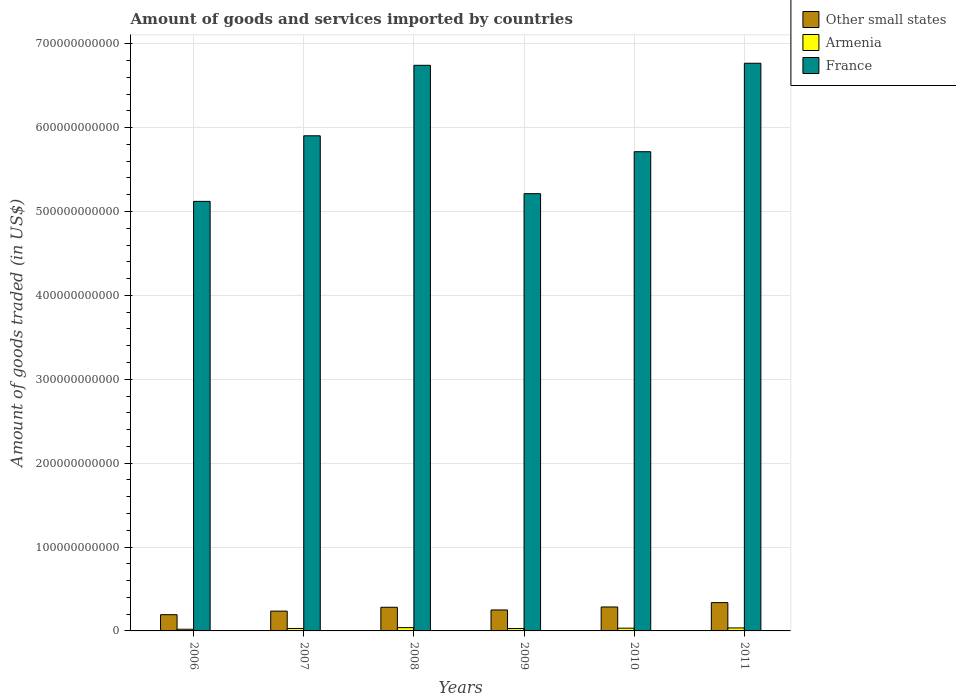How many groups of bars are there?
Your answer should be compact. 6. Are the number of bars on each tick of the X-axis equal?
Provide a succinct answer. Yes. How many bars are there on the 2nd tick from the left?
Provide a short and direct response. 3. What is the label of the 3rd group of bars from the left?
Your answer should be compact. 2008. What is the total amount of goods and services imported in France in 2011?
Keep it short and to the point. 6.77e+11. Across all years, what is the maximum total amount of goods and services imported in France?
Your answer should be very brief. 6.77e+11. Across all years, what is the minimum total amount of goods and services imported in Other small states?
Your response must be concise. 1.93e+1. In which year was the total amount of goods and services imported in Other small states minimum?
Keep it short and to the point. 2006. What is the total total amount of goods and services imported in Armenia in the graph?
Provide a succinct answer. 1.85e+1. What is the difference between the total amount of goods and services imported in Armenia in 2007 and that in 2008?
Offer a very short reply. -1.00e+09. What is the difference between the total amount of goods and services imported in Armenia in 2008 and the total amount of goods and services imported in France in 2006?
Ensure brevity in your answer.  -5.08e+11. What is the average total amount of goods and services imported in Armenia per year?
Your response must be concise. 3.09e+09. In the year 2007, what is the difference between the total amount of goods and services imported in Other small states and total amount of goods and services imported in France?
Give a very brief answer. -5.67e+11. What is the ratio of the total amount of goods and services imported in Armenia in 2006 to that in 2010?
Give a very brief answer. 0.61. Is the difference between the total amount of goods and services imported in Other small states in 2007 and 2011 greater than the difference between the total amount of goods and services imported in France in 2007 and 2011?
Provide a succinct answer. Yes. What is the difference between the highest and the second highest total amount of goods and services imported in Armenia?
Ensure brevity in your answer.  3.81e+08. What is the difference between the highest and the lowest total amount of goods and services imported in France?
Your answer should be very brief. 1.65e+11. In how many years, is the total amount of goods and services imported in Armenia greater than the average total amount of goods and services imported in Armenia taken over all years?
Make the answer very short. 3. Is the sum of the total amount of goods and services imported in France in 2009 and 2011 greater than the maximum total amount of goods and services imported in Armenia across all years?
Make the answer very short. Yes. What does the 2nd bar from the left in 2006 represents?
Your response must be concise. Armenia. What does the 2nd bar from the right in 2009 represents?
Your answer should be very brief. Armenia. Is it the case that in every year, the sum of the total amount of goods and services imported in France and total amount of goods and services imported in Armenia is greater than the total amount of goods and services imported in Other small states?
Provide a succinct answer. Yes. How many bars are there?
Offer a very short reply. 18. How many years are there in the graph?
Your answer should be very brief. 6. What is the difference between two consecutive major ticks on the Y-axis?
Your answer should be very brief. 1.00e+11. Does the graph contain grids?
Provide a short and direct response. Yes. Where does the legend appear in the graph?
Ensure brevity in your answer.  Top right. How many legend labels are there?
Provide a succinct answer. 3. How are the legend labels stacked?
Offer a terse response. Vertical. What is the title of the graph?
Keep it short and to the point. Amount of goods and services imported by countries. Does "East Asia (all income levels)" appear as one of the legend labels in the graph?
Provide a short and direct response. No. What is the label or title of the Y-axis?
Provide a short and direct response. Amount of goods traded (in US$). What is the Amount of goods traded (in US$) in Other small states in 2006?
Provide a short and direct response. 1.93e+1. What is the Amount of goods traded (in US$) of Armenia in 2006?
Offer a very short reply. 2.00e+09. What is the Amount of goods traded (in US$) of France in 2006?
Offer a very short reply. 5.12e+11. What is the Amount of goods traded (in US$) in Other small states in 2007?
Give a very brief answer. 2.36e+1. What is the Amount of goods traded (in US$) of Armenia in 2007?
Provide a short and direct response. 2.92e+09. What is the Amount of goods traded (in US$) of France in 2007?
Offer a very short reply. 5.90e+11. What is the Amount of goods traded (in US$) of Other small states in 2008?
Ensure brevity in your answer.  2.82e+1. What is the Amount of goods traded (in US$) of Armenia in 2008?
Offer a very short reply. 3.92e+09. What is the Amount of goods traded (in US$) of France in 2008?
Ensure brevity in your answer.  6.74e+11. What is the Amount of goods traded (in US$) in Other small states in 2009?
Your answer should be very brief. 2.50e+1. What is the Amount of goods traded (in US$) of Armenia in 2009?
Provide a succinct answer. 2.86e+09. What is the Amount of goods traded (in US$) in France in 2009?
Ensure brevity in your answer.  5.21e+11. What is the Amount of goods traded (in US$) in Other small states in 2010?
Make the answer very short. 2.86e+1. What is the Amount of goods traded (in US$) of Armenia in 2010?
Your answer should be very brief. 3.26e+09. What is the Amount of goods traded (in US$) of France in 2010?
Give a very brief answer. 5.71e+11. What is the Amount of goods traded (in US$) in Other small states in 2011?
Offer a very short reply. 3.37e+1. What is the Amount of goods traded (in US$) of Armenia in 2011?
Your response must be concise. 3.54e+09. What is the Amount of goods traded (in US$) in France in 2011?
Provide a short and direct response. 6.77e+11. Across all years, what is the maximum Amount of goods traded (in US$) of Other small states?
Ensure brevity in your answer.  3.37e+1. Across all years, what is the maximum Amount of goods traded (in US$) in Armenia?
Ensure brevity in your answer.  3.92e+09. Across all years, what is the maximum Amount of goods traded (in US$) of France?
Make the answer very short. 6.77e+11. Across all years, what is the minimum Amount of goods traded (in US$) of Other small states?
Provide a succinct answer. 1.93e+1. Across all years, what is the minimum Amount of goods traded (in US$) in Armenia?
Offer a very short reply. 2.00e+09. Across all years, what is the minimum Amount of goods traded (in US$) of France?
Your answer should be very brief. 5.12e+11. What is the total Amount of goods traded (in US$) of Other small states in the graph?
Give a very brief answer. 1.58e+11. What is the total Amount of goods traded (in US$) of Armenia in the graph?
Your answer should be compact. 1.85e+1. What is the total Amount of goods traded (in US$) of France in the graph?
Your answer should be very brief. 3.55e+12. What is the difference between the Amount of goods traded (in US$) of Other small states in 2006 and that in 2007?
Give a very brief answer. -4.27e+09. What is the difference between the Amount of goods traded (in US$) in Armenia in 2006 and that in 2007?
Offer a terse response. -9.21e+08. What is the difference between the Amount of goods traded (in US$) in France in 2006 and that in 2007?
Offer a terse response. -7.82e+1. What is the difference between the Amount of goods traded (in US$) of Other small states in 2006 and that in 2008?
Your answer should be compact. -8.85e+09. What is the difference between the Amount of goods traded (in US$) of Armenia in 2006 and that in 2008?
Offer a terse response. -1.92e+09. What is the difference between the Amount of goods traded (in US$) in France in 2006 and that in 2008?
Ensure brevity in your answer.  -1.62e+11. What is the difference between the Amount of goods traded (in US$) of Other small states in 2006 and that in 2009?
Provide a succinct answer. -5.65e+09. What is the difference between the Amount of goods traded (in US$) in Armenia in 2006 and that in 2009?
Offer a terse response. -8.64e+08. What is the difference between the Amount of goods traded (in US$) in France in 2006 and that in 2009?
Your answer should be compact. -9.15e+09. What is the difference between the Amount of goods traded (in US$) in Other small states in 2006 and that in 2010?
Give a very brief answer. -9.21e+09. What is the difference between the Amount of goods traded (in US$) of Armenia in 2006 and that in 2010?
Ensure brevity in your answer.  -1.26e+09. What is the difference between the Amount of goods traded (in US$) in France in 2006 and that in 2010?
Offer a terse response. -5.92e+1. What is the difference between the Amount of goods traded (in US$) in Other small states in 2006 and that in 2011?
Offer a very short reply. -1.44e+1. What is the difference between the Amount of goods traded (in US$) in Armenia in 2006 and that in 2011?
Give a very brief answer. -1.54e+09. What is the difference between the Amount of goods traded (in US$) in France in 2006 and that in 2011?
Ensure brevity in your answer.  -1.65e+11. What is the difference between the Amount of goods traded (in US$) in Other small states in 2007 and that in 2008?
Your answer should be very brief. -4.57e+09. What is the difference between the Amount of goods traded (in US$) in Armenia in 2007 and that in 2008?
Keep it short and to the point. -1.00e+09. What is the difference between the Amount of goods traded (in US$) in France in 2007 and that in 2008?
Offer a terse response. -8.40e+1. What is the difference between the Amount of goods traded (in US$) in Other small states in 2007 and that in 2009?
Make the answer very short. -1.38e+09. What is the difference between the Amount of goods traded (in US$) of Armenia in 2007 and that in 2009?
Offer a terse response. 5.75e+07. What is the difference between the Amount of goods traded (in US$) in France in 2007 and that in 2009?
Make the answer very short. 6.90e+1. What is the difference between the Amount of goods traded (in US$) of Other small states in 2007 and that in 2010?
Make the answer very short. -4.94e+09. What is the difference between the Amount of goods traded (in US$) of Armenia in 2007 and that in 2010?
Your answer should be compact. -3.42e+08. What is the difference between the Amount of goods traded (in US$) in France in 2007 and that in 2010?
Your answer should be compact. 1.90e+1. What is the difference between the Amount of goods traded (in US$) of Other small states in 2007 and that in 2011?
Provide a short and direct response. -1.01e+1. What is the difference between the Amount of goods traded (in US$) in Armenia in 2007 and that in 2011?
Offer a very short reply. -6.20e+08. What is the difference between the Amount of goods traded (in US$) of France in 2007 and that in 2011?
Give a very brief answer. -8.65e+1. What is the difference between the Amount of goods traded (in US$) of Other small states in 2008 and that in 2009?
Give a very brief answer. 3.19e+09. What is the difference between the Amount of goods traded (in US$) of Armenia in 2008 and that in 2009?
Offer a terse response. 1.06e+09. What is the difference between the Amount of goods traded (in US$) in France in 2008 and that in 2009?
Offer a very short reply. 1.53e+11. What is the difference between the Amount of goods traded (in US$) of Other small states in 2008 and that in 2010?
Your response must be concise. -3.67e+08. What is the difference between the Amount of goods traded (in US$) of Armenia in 2008 and that in 2010?
Give a very brief answer. 6.59e+08. What is the difference between the Amount of goods traded (in US$) in France in 2008 and that in 2010?
Offer a terse response. 1.03e+11. What is the difference between the Amount of goods traded (in US$) of Other small states in 2008 and that in 2011?
Make the answer very short. -5.55e+09. What is the difference between the Amount of goods traded (in US$) in Armenia in 2008 and that in 2011?
Make the answer very short. 3.81e+08. What is the difference between the Amount of goods traded (in US$) in France in 2008 and that in 2011?
Your answer should be compact. -2.45e+09. What is the difference between the Amount of goods traded (in US$) of Other small states in 2009 and that in 2010?
Keep it short and to the point. -3.56e+09. What is the difference between the Amount of goods traded (in US$) in Armenia in 2009 and that in 2010?
Provide a succinct answer. -4.00e+08. What is the difference between the Amount of goods traded (in US$) in France in 2009 and that in 2010?
Your response must be concise. -5.01e+1. What is the difference between the Amount of goods traded (in US$) of Other small states in 2009 and that in 2011?
Your answer should be compact. -8.75e+09. What is the difference between the Amount of goods traded (in US$) in Armenia in 2009 and that in 2011?
Keep it short and to the point. -6.78e+08. What is the difference between the Amount of goods traded (in US$) in France in 2009 and that in 2011?
Provide a short and direct response. -1.56e+11. What is the difference between the Amount of goods traded (in US$) of Other small states in 2010 and that in 2011?
Offer a very short reply. -5.18e+09. What is the difference between the Amount of goods traded (in US$) in Armenia in 2010 and that in 2011?
Make the answer very short. -2.78e+08. What is the difference between the Amount of goods traded (in US$) in France in 2010 and that in 2011?
Provide a short and direct response. -1.05e+11. What is the difference between the Amount of goods traded (in US$) of Other small states in 2006 and the Amount of goods traded (in US$) of Armenia in 2007?
Make the answer very short. 1.64e+1. What is the difference between the Amount of goods traded (in US$) in Other small states in 2006 and the Amount of goods traded (in US$) in France in 2007?
Provide a succinct answer. -5.71e+11. What is the difference between the Amount of goods traded (in US$) in Armenia in 2006 and the Amount of goods traded (in US$) in France in 2007?
Your answer should be very brief. -5.88e+11. What is the difference between the Amount of goods traded (in US$) of Other small states in 2006 and the Amount of goods traded (in US$) of Armenia in 2008?
Keep it short and to the point. 1.54e+1. What is the difference between the Amount of goods traded (in US$) in Other small states in 2006 and the Amount of goods traded (in US$) in France in 2008?
Keep it short and to the point. -6.55e+11. What is the difference between the Amount of goods traded (in US$) in Armenia in 2006 and the Amount of goods traded (in US$) in France in 2008?
Your response must be concise. -6.72e+11. What is the difference between the Amount of goods traded (in US$) in Other small states in 2006 and the Amount of goods traded (in US$) in Armenia in 2009?
Provide a short and direct response. 1.65e+1. What is the difference between the Amount of goods traded (in US$) of Other small states in 2006 and the Amount of goods traded (in US$) of France in 2009?
Your response must be concise. -5.02e+11. What is the difference between the Amount of goods traded (in US$) in Armenia in 2006 and the Amount of goods traded (in US$) in France in 2009?
Your answer should be very brief. -5.19e+11. What is the difference between the Amount of goods traded (in US$) in Other small states in 2006 and the Amount of goods traded (in US$) in Armenia in 2010?
Ensure brevity in your answer.  1.61e+1. What is the difference between the Amount of goods traded (in US$) of Other small states in 2006 and the Amount of goods traded (in US$) of France in 2010?
Make the answer very short. -5.52e+11. What is the difference between the Amount of goods traded (in US$) in Armenia in 2006 and the Amount of goods traded (in US$) in France in 2010?
Ensure brevity in your answer.  -5.69e+11. What is the difference between the Amount of goods traded (in US$) of Other small states in 2006 and the Amount of goods traded (in US$) of Armenia in 2011?
Ensure brevity in your answer.  1.58e+1. What is the difference between the Amount of goods traded (in US$) of Other small states in 2006 and the Amount of goods traded (in US$) of France in 2011?
Your answer should be very brief. -6.57e+11. What is the difference between the Amount of goods traded (in US$) of Armenia in 2006 and the Amount of goods traded (in US$) of France in 2011?
Keep it short and to the point. -6.75e+11. What is the difference between the Amount of goods traded (in US$) in Other small states in 2007 and the Amount of goods traded (in US$) in Armenia in 2008?
Offer a very short reply. 1.97e+1. What is the difference between the Amount of goods traded (in US$) of Other small states in 2007 and the Amount of goods traded (in US$) of France in 2008?
Give a very brief answer. -6.51e+11. What is the difference between the Amount of goods traded (in US$) in Armenia in 2007 and the Amount of goods traded (in US$) in France in 2008?
Ensure brevity in your answer.  -6.71e+11. What is the difference between the Amount of goods traded (in US$) of Other small states in 2007 and the Amount of goods traded (in US$) of Armenia in 2009?
Your answer should be compact. 2.07e+1. What is the difference between the Amount of goods traded (in US$) of Other small states in 2007 and the Amount of goods traded (in US$) of France in 2009?
Make the answer very short. -4.98e+11. What is the difference between the Amount of goods traded (in US$) of Armenia in 2007 and the Amount of goods traded (in US$) of France in 2009?
Give a very brief answer. -5.18e+11. What is the difference between the Amount of goods traded (in US$) of Other small states in 2007 and the Amount of goods traded (in US$) of Armenia in 2010?
Provide a short and direct response. 2.03e+1. What is the difference between the Amount of goods traded (in US$) in Other small states in 2007 and the Amount of goods traded (in US$) in France in 2010?
Your answer should be compact. -5.48e+11. What is the difference between the Amount of goods traded (in US$) of Armenia in 2007 and the Amount of goods traded (in US$) of France in 2010?
Your answer should be very brief. -5.68e+11. What is the difference between the Amount of goods traded (in US$) of Other small states in 2007 and the Amount of goods traded (in US$) of Armenia in 2011?
Your answer should be very brief. 2.01e+1. What is the difference between the Amount of goods traded (in US$) of Other small states in 2007 and the Amount of goods traded (in US$) of France in 2011?
Keep it short and to the point. -6.53e+11. What is the difference between the Amount of goods traded (in US$) in Armenia in 2007 and the Amount of goods traded (in US$) in France in 2011?
Offer a terse response. -6.74e+11. What is the difference between the Amount of goods traded (in US$) in Other small states in 2008 and the Amount of goods traded (in US$) in Armenia in 2009?
Provide a short and direct response. 2.53e+1. What is the difference between the Amount of goods traded (in US$) in Other small states in 2008 and the Amount of goods traded (in US$) in France in 2009?
Offer a very short reply. -4.93e+11. What is the difference between the Amount of goods traded (in US$) of Armenia in 2008 and the Amount of goods traded (in US$) of France in 2009?
Provide a succinct answer. -5.17e+11. What is the difference between the Amount of goods traded (in US$) in Other small states in 2008 and the Amount of goods traded (in US$) in Armenia in 2010?
Your answer should be very brief. 2.49e+1. What is the difference between the Amount of goods traded (in US$) in Other small states in 2008 and the Amount of goods traded (in US$) in France in 2010?
Your answer should be compact. -5.43e+11. What is the difference between the Amount of goods traded (in US$) in Armenia in 2008 and the Amount of goods traded (in US$) in France in 2010?
Your answer should be very brief. -5.67e+11. What is the difference between the Amount of goods traded (in US$) of Other small states in 2008 and the Amount of goods traded (in US$) of Armenia in 2011?
Ensure brevity in your answer.  2.46e+1. What is the difference between the Amount of goods traded (in US$) in Other small states in 2008 and the Amount of goods traded (in US$) in France in 2011?
Keep it short and to the point. -6.49e+11. What is the difference between the Amount of goods traded (in US$) of Armenia in 2008 and the Amount of goods traded (in US$) of France in 2011?
Your response must be concise. -6.73e+11. What is the difference between the Amount of goods traded (in US$) in Other small states in 2009 and the Amount of goods traded (in US$) in Armenia in 2010?
Offer a terse response. 2.17e+1. What is the difference between the Amount of goods traded (in US$) of Other small states in 2009 and the Amount of goods traded (in US$) of France in 2010?
Offer a very short reply. -5.46e+11. What is the difference between the Amount of goods traded (in US$) in Armenia in 2009 and the Amount of goods traded (in US$) in France in 2010?
Provide a succinct answer. -5.68e+11. What is the difference between the Amount of goods traded (in US$) of Other small states in 2009 and the Amount of goods traded (in US$) of Armenia in 2011?
Ensure brevity in your answer.  2.15e+1. What is the difference between the Amount of goods traded (in US$) in Other small states in 2009 and the Amount of goods traded (in US$) in France in 2011?
Make the answer very short. -6.52e+11. What is the difference between the Amount of goods traded (in US$) of Armenia in 2009 and the Amount of goods traded (in US$) of France in 2011?
Make the answer very short. -6.74e+11. What is the difference between the Amount of goods traded (in US$) of Other small states in 2010 and the Amount of goods traded (in US$) of Armenia in 2011?
Keep it short and to the point. 2.50e+1. What is the difference between the Amount of goods traded (in US$) of Other small states in 2010 and the Amount of goods traded (in US$) of France in 2011?
Provide a succinct answer. -6.48e+11. What is the difference between the Amount of goods traded (in US$) of Armenia in 2010 and the Amount of goods traded (in US$) of France in 2011?
Provide a short and direct response. -6.74e+11. What is the average Amount of goods traded (in US$) in Other small states per year?
Offer a very short reply. 2.64e+1. What is the average Amount of goods traded (in US$) of Armenia per year?
Ensure brevity in your answer.  3.09e+09. What is the average Amount of goods traded (in US$) in France per year?
Offer a terse response. 5.91e+11. In the year 2006, what is the difference between the Amount of goods traded (in US$) in Other small states and Amount of goods traded (in US$) in Armenia?
Provide a succinct answer. 1.73e+1. In the year 2006, what is the difference between the Amount of goods traded (in US$) in Other small states and Amount of goods traded (in US$) in France?
Offer a very short reply. -4.93e+11. In the year 2006, what is the difference between the Amount of goods traded (in US$) of Armenia and Amount of goods traded (in US$) of France?
Your answer should be compact. -5.10e+11. In the year 2007, what is the difference between the Amount of goods traded (in US$) of Other small states and Amount of goods traded (in US$) of Armenia?
Provide a short and direct response. 2.07e+1. In the year 2007, what is the difference between the Amount of goods traded (in US$) of Other small states and Amount of goods traded (in US$) of France?
Your answer should be very brief. -5.67e+11. In the year 2007, what is the difference between the Amount of goods traded (in US$) in Armenia and Amount of goods traded (in US$) in France?
Keep it short and to the point. -5.87e+11. In the year 2008, what is the difference between the Amount of goods traded (in US$) in Other small states and Amount of goods traded (in US$) in Armenia?
Offer a terse response. 2.43e+1. In the year 2008, what is the difference between the Amount of goods traded (in US$) of Other small states and Amount of goods traded (in US$) of France?
Offer a terse response. -6.46e+11. In the year 2008, what is the difference between the Amount of goods traded (in US$) in Armenia and Amount of goods traded (in US$) in France?
Your response must be concise. -6.70e+11. In the year 2009, what is the difference between the Amount of goods traded (in US$) in Other small states and Amount of goods traded (in US$) in Armenia?
Provide a succinct answer. 2.21e+1. In the year 2009, what is the difference between the Amount of goods traded (in US$) in Other small states and Amount of goods traded (in US$) in France?
Your answer should be compact. -4.96e+11. In the year 2009, what is the difference between the Amount of goods traded (in US$) of Armenia and Amount of goods traded (in US$) of France?
Keep it short and to the point. -5.18e+11. In the year 2010, what is the difference between the Amount of goods traded (in US$) in Other small states and Amount of goods traded (in US$) in Armenia?
Offer a very short reply. 2.53e+1. In the year 2010, what is the difference between the Amount of goods traded (in US$) of Other small states and Amount of goods traded (in US$) of France?
Provide a short and direct response. -5.43e+11. In the year 2010, what is the difference between the Amount of goods traded (in US$) of Armenia and Amount of goods traded (in US$) of France?
Your response must be concise. -5.68e+11. In the year 2011, what is the difference between the Amount of goods traded (in US$) in Other small states and Amount of goods traded (in US$) in Armenia?
Your answer should be very brief. 3.02e+1. In the year 2011, what is the difference between the Amount of goods traded (in US$) in Other small states and Amount of goods traded (in US$) in France?
Give a very brief answer. -6.43e+11. In the year 2011, what is the difference between the Amount of goods traded (in US$) of Armenia and Amount of goods traded (in US$) of France?
Make the answer very short. -6.73e+11. What is the ratio of the Amount of goods traded (in US$) in Other small states in 2006 to that in 2007?
Provide a succinct answer. 0.82. What is the ratio of the Amount of goods traded (in US$) of Armenia in 2006 to that in 2007?
Offer a terse response. 0.68. What is the ratio of the Amount of goods traded (in US$) of France in 2006 to that in 2007?
Offer a terse response. 0.87. What is the ratio of the Amount of goods traded (in US$) of Other small states in 2006 to that in 2008?
Your answer should be very brief. 0.69. What is the ratio of the Amount of goods traded (in US$) in Armenia in 2006 to that in 2008?
Give a very brief answer. 0.51. What is the ratio of the Amount of goods traded (in US$) in France in 2006 to that in 2008?
Provide a short and direct response. 0.76. What is the ratio of the Amount of goods traded (in US$) in Other small states in 2006 to that in 2009?
Your response must be concise. 0.77. What is the ratio of the Amount of goods traded (in US$) of Armenia in 2006 to that in 2009?
Offer a terse response. 0.7. What is the ratio of the Amount of goods traded (in US$) in France in 2006 to that in 2009?
Offer a terse response. 0.98. What is the ratio of the Amount of goods traded (in US$) in Other small states in 2006 to that in 2010?
Give a very brief answer. 0.68. What is the ratio of the Amount of goods traded (in US$) of Armenia in 2006 to that in 2010?
Provide a succinct answer. 0.61. What is the ratio of the Amount of goods traded (in US$) in France in 2006 to that in 2010?
Your response must be concise. 0.9. What is the ratio of the Amount of goods traded (in US$) of Other small states in 2006 to that in 2011?
Offer a terse response. 0.57. What is the ratio of the Amount of goods traded (in US$) of Armenia in 2006 to that in 2011?
Your answer should be very brief. 0.56. What is the ratio of the Amount of goods traded (in US$) in France in 2006 to that in 2011?
Keep it short and to the point. 0.76. What is the ratio of the Amount of goods traded (in US$) in Other small states in 2007 to that in 2008?
Provide a succinct answer. 0.84. What is the ratio of the Amount of goods traded (in US$) of Armenia in 2007 to that in 2008?
Your answer should be very brief. 0.74. What is the ratio of the Amount of goods traded (in US$) in France in 2007 to that in 2008?
Offer a very short reply. 0.88. What is the ratio of the Amount of goods traded (in US$) of Other small states in 2007 to that in 2009?
Your answer should be very brief. 0.94. What is the ratio of the Amount of goods traded (in US$) in Armenia in 2007 to that in 2009?
Your answer should be compact. 1.02. What is the ratio of the Amount of goods traded (in US$) of France in 2007 to that in 2009?
Your answer should be compact. 1.13. What is the ratio of the Amount of goods traded (in US$) of Other small states in 2007 to that in 2010?
Give a very brief answer. 0.83. What is the ratio of the Amount of goods traded (in US$) in Armenia in 2007 to that in 2010?
Provide a succinct answer. 0.9. What is the ratio of the Amount of goods traded (in US$) in France in 2007 to that in 2010?
Your response must be concise. 1.03. What is the ratio of the Amount of goods traded (in US$) in Other small states in 2007 to that in 2011?
Give a very brief answer. 0.7. What is the ratio of the Amount of goods traded (in US$) in Armenia in 2007 to that in 2011?
Give a very brief answer. 0.82. What is the ratio of the Amount of goods traded (in US$) of France in 2007 to that in 2011?
Make the answer very short. 0.87. What is the ratio of the Amount of goods traded (in US$) of Other small states in 2008 to that in 2009?
Ensure brevity in your answer.  1.13. What is the ratio of the Amount of goods traded (in US$) in Armenia in 2008 to that in 2009?
Ensure brevity in your answer.  1.37. What is the ratio of the Amount of goods traded (in US$) in France in 2008 to that in 2009?
Offer a very short reply. 1.29. What is the ratio of the Amount of goods traded (in US$) in Other small states in 2008 to that in 2010?
Give a very brief answer. 0.99. What is the ratio of the Amount of goods traded (in US$) of Armenia in 2008 to that in 2010?
Make the answer very short. 1.2. What is the ratio of the Amount of goods traded (in US$) in France in 2008 to that in 2010?
Make the answer very short. 1.18. What is the ratio of the Amount of goods traded (in US$) of Other small states in 2008 to that in 2011?
Keep it short and to the point. 0.84. What is the ratio of the Amount of goods traded (in US$) of Armenia in 2008 to that in 2011?
Your answer should be very brief. 1.11. What is the ratio of the Amount of goods traded (in US$) in Other small states in 2009 to that in 2010?
Offer a very short reply. 0.88. What is the ratio of the Amount of goods traded (in US$) of Armenia in 2009 to that in 2010?
Offer a terse response. 0.88. What is the ratio of the Amount of goods traded (in US$) of France in 2009 to that in 2010?
Your answer should be very brief. 0.91. What is the ratio of the Amount of goods traded (in US$) of Other small states in 2009 to that in 2011?
Your response must be concise. 0.74. What is the ratio of the Amount of goods traded (in US$) of Armenia in 2009 to that in 2011?
Your answer should be very brief. 0.81. What is the ratio of the Amount of goods traded (in US$) of France in 2009 to that in 2011?
Your answer should be very brief. 0.77. What is the ratio of the Amount of goods traded (in US$) in Other small states in 2010 to that in 2011?
Provide a short and direct response. 0.85. What is the ratio of the Amount of goods traded (in US$) of Armenia in 2010 to that in 2011?
Provide a succinct answer. 0.92. What is the ratio of the Amount of goods traded (in US$) of France in 2010 to that in 2011?
Your answer should be compact. 0.84. What is the difference between the highest and the second highest Amount of goods traded (in US$) in Other small states?
Make the answer very short. 5.18e+09. What is the difference between the highest and the second highest Amount of goods traded (in US$) of Armenia?
Keep it short and to the point. 3.81e+08. What is the difference between the highest and the second highest Amount of goods traded (in US$) of France?
Your response must be concise. 2.45e+09. What is the difference between the highest and the lowest Amount of goods traded (in US$) of Other small states?
Offer a terse response. 1.44e+1. What is the difference between the highest and the lowest Amount of goods traded (in US$) of Armenia?
Provide a succinct answer. 1.92e+09. What is the difference between the highest and the lowest Amount of goods traded (in US$) in France?
Make the answer very short. 1.65e+11. 